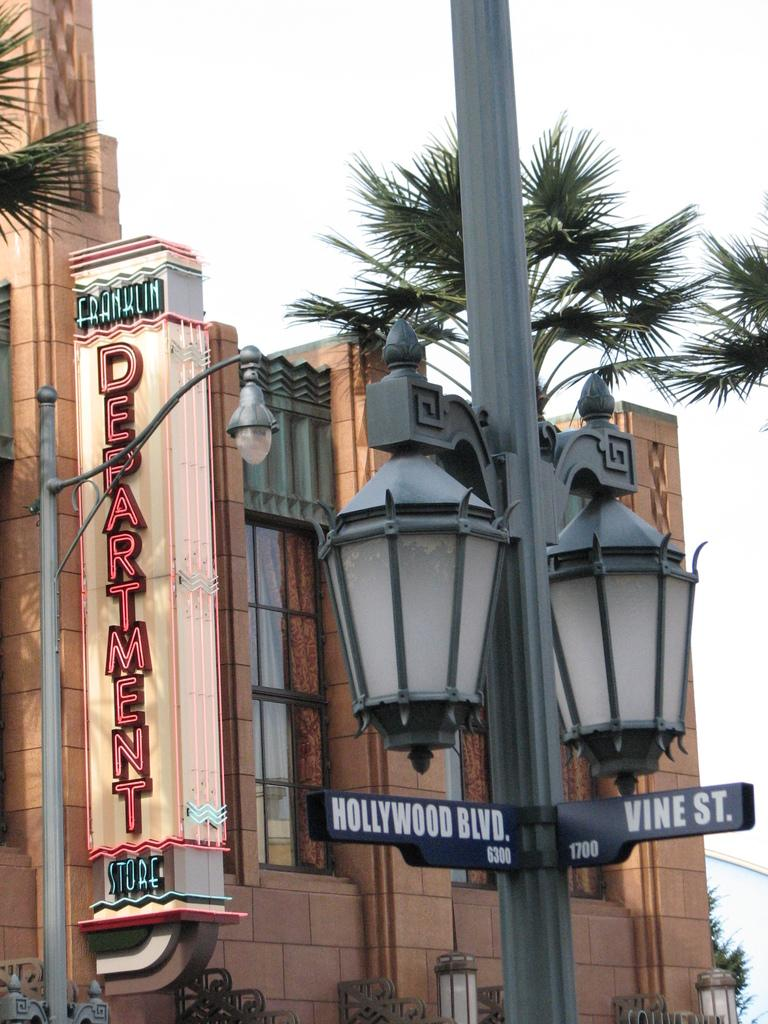<image>
Present a compact description of the photo's key features. hollywood blvs street sign and building on display 